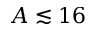<formula> <loc_0><loc_0><loc_500><loc_500>A \lesssim 1 6</formula> 